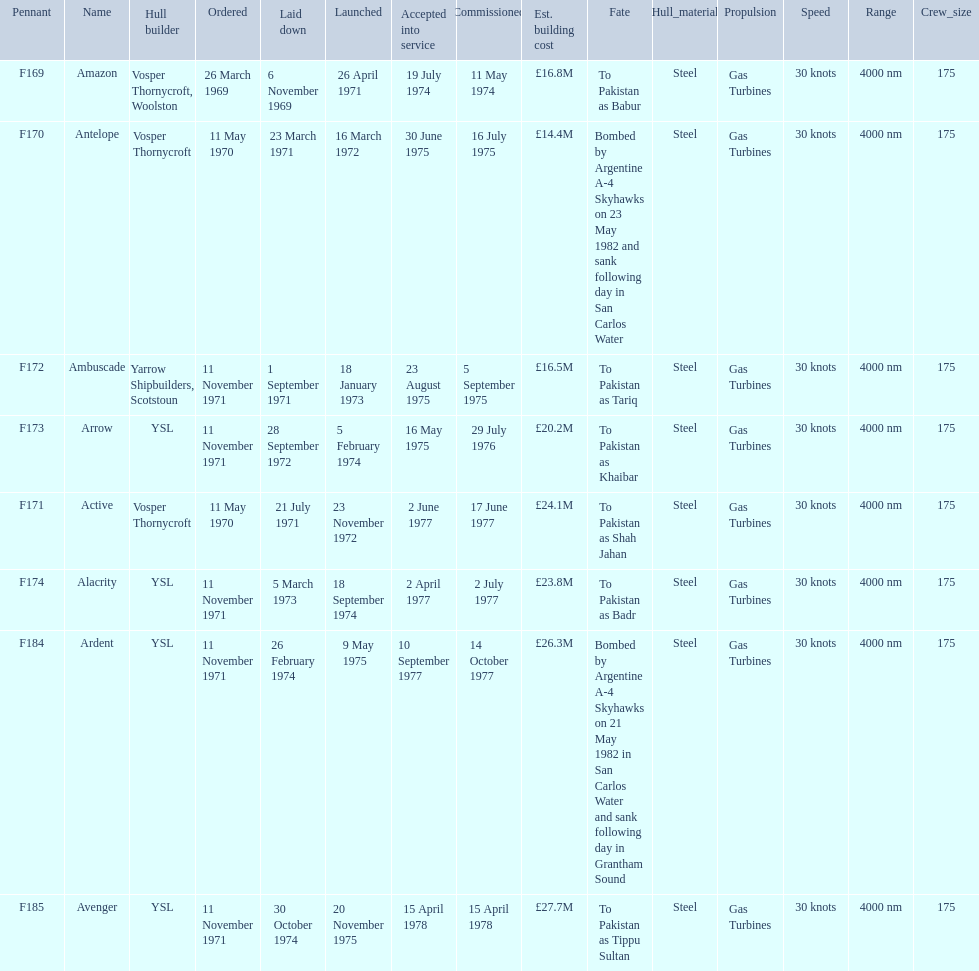Which type 21 frigate ships were to be built by ysl in the 1970s? Arrow, Alacrity, Ardent, Avenger. Of these ships, which one had the highest estimated building cost? Avenger. 